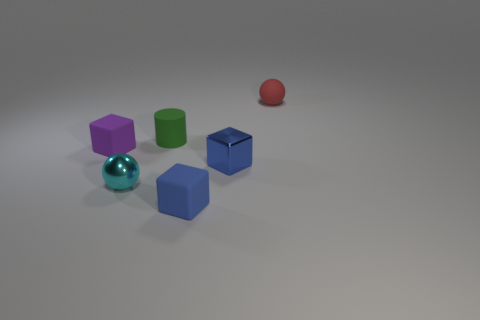Add 3 tiny matte cylinders. How many objects exist? 9 Subtract all spheres. How many objects are left? 4 Subtract 1 purple blocks. How many objects are left? 5 Subtract all blue matte cubes. Subtract all tiny red matte things. How many objects are left? 4 Add 3 tiny shiny spheres. How many tiny shiny spheres are left? 4 Add 2 blue rubber blocks. How many blue rubber blocks exist? 3 